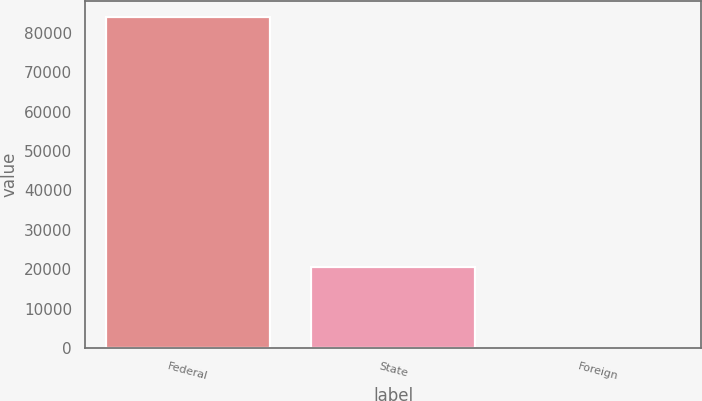Convert chart. <chart><loc_0><loc_0><loc_500><loc_500><bar_chart><fcel>Federal<fcel>State<fcel>Foreign<nl><fcel>83990<fcel>20604<fcel>97<nl></chart> 